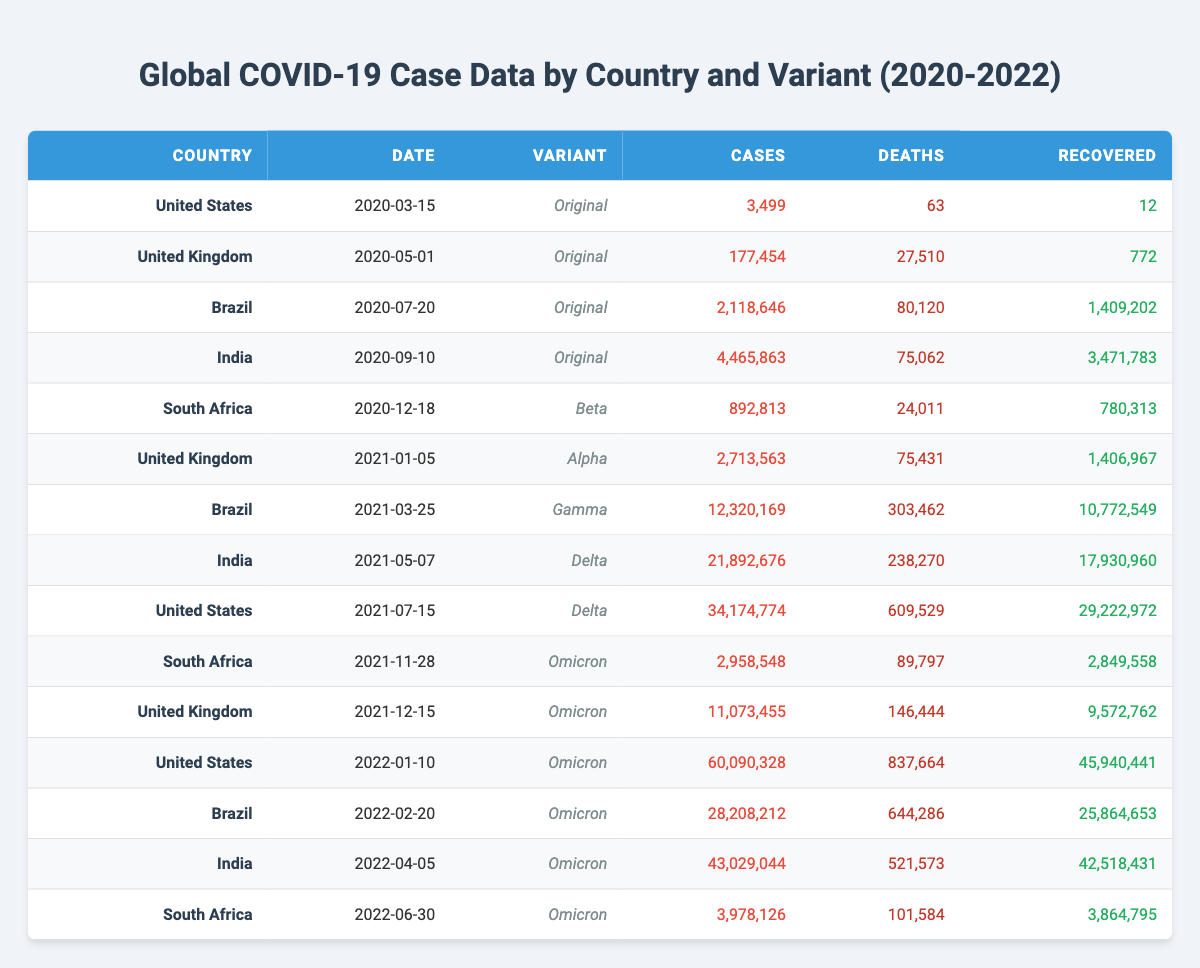What is the total number of cases reported in the United States? To find the total cases for the United States, we need to sum all cases listed under this country. The cases are: 3,499 (2020), 34,174,774 (2021), and 60,090,328 (2022). Adding these values gives us: 3,499 + 34,174,774 + 60,090,328 = 94,268,601.
Answer: 94,268,601 Which COVID variant had the highest number of cases in Brazil? Looking through Brazil's entries, the variants and their cases are: Original (2,118,646), Gamma (12,320,169), and Omicron (28,208,212). The highest number of cases belongs to the Omicron variant with 28,208,212 cases.
Answer: Omicron True or False: India had more cases than the United States on January 10, 2022. On January 10, 2022, India reported 43,029,044 cases (Omicron variant), while the United States reported 60,090,328 cases (also Omicron variant). Since 43,029,044 is less than 60,090,328, the statement is false.
Answer: False What is the total number of deaths from COVID-19 in South Africa across all variants and dates? For South Africa, the deaths recorded are: 24,011 (Beta), 89,797 (Omicron on 2021-11-28), and 101,584 (Omicron on 2022-06-30). Adding these together gives us: 24,011 + 89,797 + 101,584 = 215,392.
Answer: 215,392 True or False: The United Kingdom had more cases for the Delta variant than the Alpha variant. The cases for the Alpha variant in the United Kingdom are 2,713,563, and for Delta, there are no records of cases for the United Kingdom during that variant's surge from the data provided, thus implying that there are 0 cases. Therefore, the statement is technically true as 2,713,563 is greater than 0.
Answer: True Which country had the highest recovery rate for the Omicron variant based on reported cases and recoveries? The recovery rates for Omicron are calculated as follows: United States: 45,940,441 / 60,090,328 = 76.4%, Brazil: 25,864,653 / 28,208,212 = 91.8%, India: 42,518,431 / 43,029,044 = 98.8%, South Africa: 3,864,795 / 3,978,126 = 97.1%. The highest recovery rate is for India at 98.8%.
Answer: India How many total cases were reported from the Delta variant across all countries? The Delta cases by country are: India - 21,892,676 and United States - 34,174,774. Adding these gives: 21,892,676 + 34,174,774 = 56,067,450 cases for Delta variant across both countries.
Answer: 56,067,450 What was the total number of recoveries reported in the United Kingdom across all variants? Reviewing all data points for the United Kingdom: 772 (Original), 1,406,967 (Alpha), and 9,572,762 (Omicron), the total recoveries amount to 772 + 1,406,967 + 9,572,762 = 10,981,501 recoveries.
Answer: 10,981,501 Which dates had case totals exceeding 30 million in the United States? Only the date January 10, 2022, reported cases exceeding 30 million (60,090,328), while other dates listed had fewer cases (3,499 and 34,174,774 on July 15, 2021).
Answer: January 10, 2022 